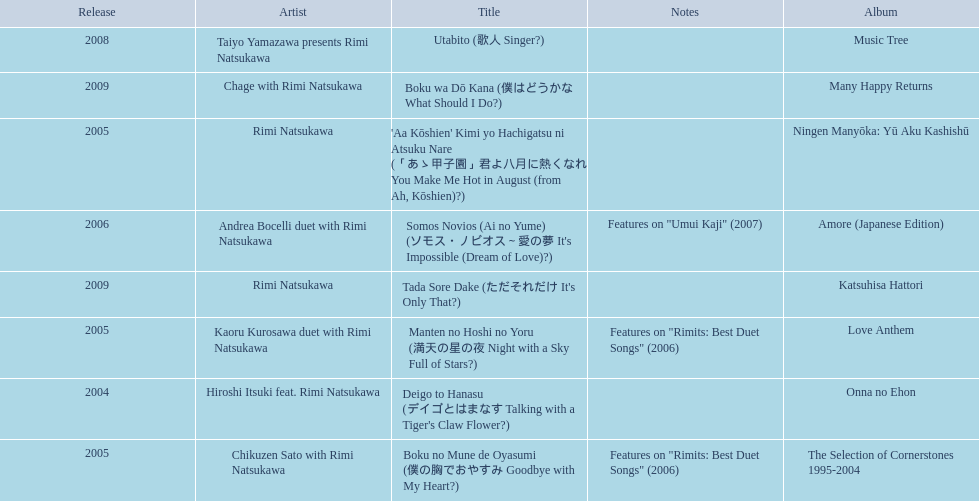What are the notes for sky full of stars? Features on "Rimits: Best Duet Songs" (2006). Could you help me parse every detail presented in this table? {'header': ['Release', 'Artist', 'Title', 'Notes', 'Album'], 'rows': [['2008', 'Taiyo Yamazawa presents Rimi Natsukawa', 'Utabito (歌人 Singer?)', '', 'Music Tree'], ['2009', 'Chage with Rimi Natsukawa', 'Boku wa Dō Kana (僕はどうかな What Should I Do?)', '', 'Many Happy Returns'], ['2005', 'Rimi Natsukawa', "'Aa Kōshien' Kimi yo Hachigatsu ni Atsuku Nare (「あゝ甲子園」君よ八月に熱くなれ You Make Me Hot in August (from Ah, Kōshien)?)", '', 'Ningen Manyōka: Yū Aku Kashishū'], ['2006', 'Andrea Bocelli duet with Rimi Natsukawa', "Somos Novios (Ai no Yume) (ソモス・ノビオス～愛の夢 It's Impossible (Dream of Love)?)", 'Features on "Umui Kaji" (2007)', 'Amore (Japanese Edition)'], ['2009', 'Rimi Natsukawa', "Tada Sore Dake (ただそれだけ It's Only That?)", '', 'Katsuhisa Hattori'], ['2005', 'Kaoru Kurosawa duet with Rimi Natsukawa', 'Manten no Hoshi no Yoru (満天の星の夜 Night with a Sky Full of Stars?)', 'Features on "Rimits: Best Duet Songs" (2006)', 'Love Anthem'], ['2004', 'Hiroshi Itsuki feat. Rimi Natsukawa', "Deigo to Hanasu (デイゴとはまなす Talking with a Tiger's Claw Flower?)", '', 'Onna no Ehon'], ['2005', 'Chikuzen Sato with Rimi Natsukawa', 'Boku no Mune de Oyasumi (僕の胸でおやすみ Goodbye with My Heart?)', 'Features on "Rimits: Best Duet Songs" (2006)', 'The Selection of Cornerstones 1995-2004']]} What other song features this same note? Boku no Mune de Oyasumi (僕の胸でおやすみ Goodbye with My Heart?). 